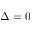Convert formula to latex. <formula><loc_0><loc_0><loc_500><loc_500>\Delta = 0</formula> 